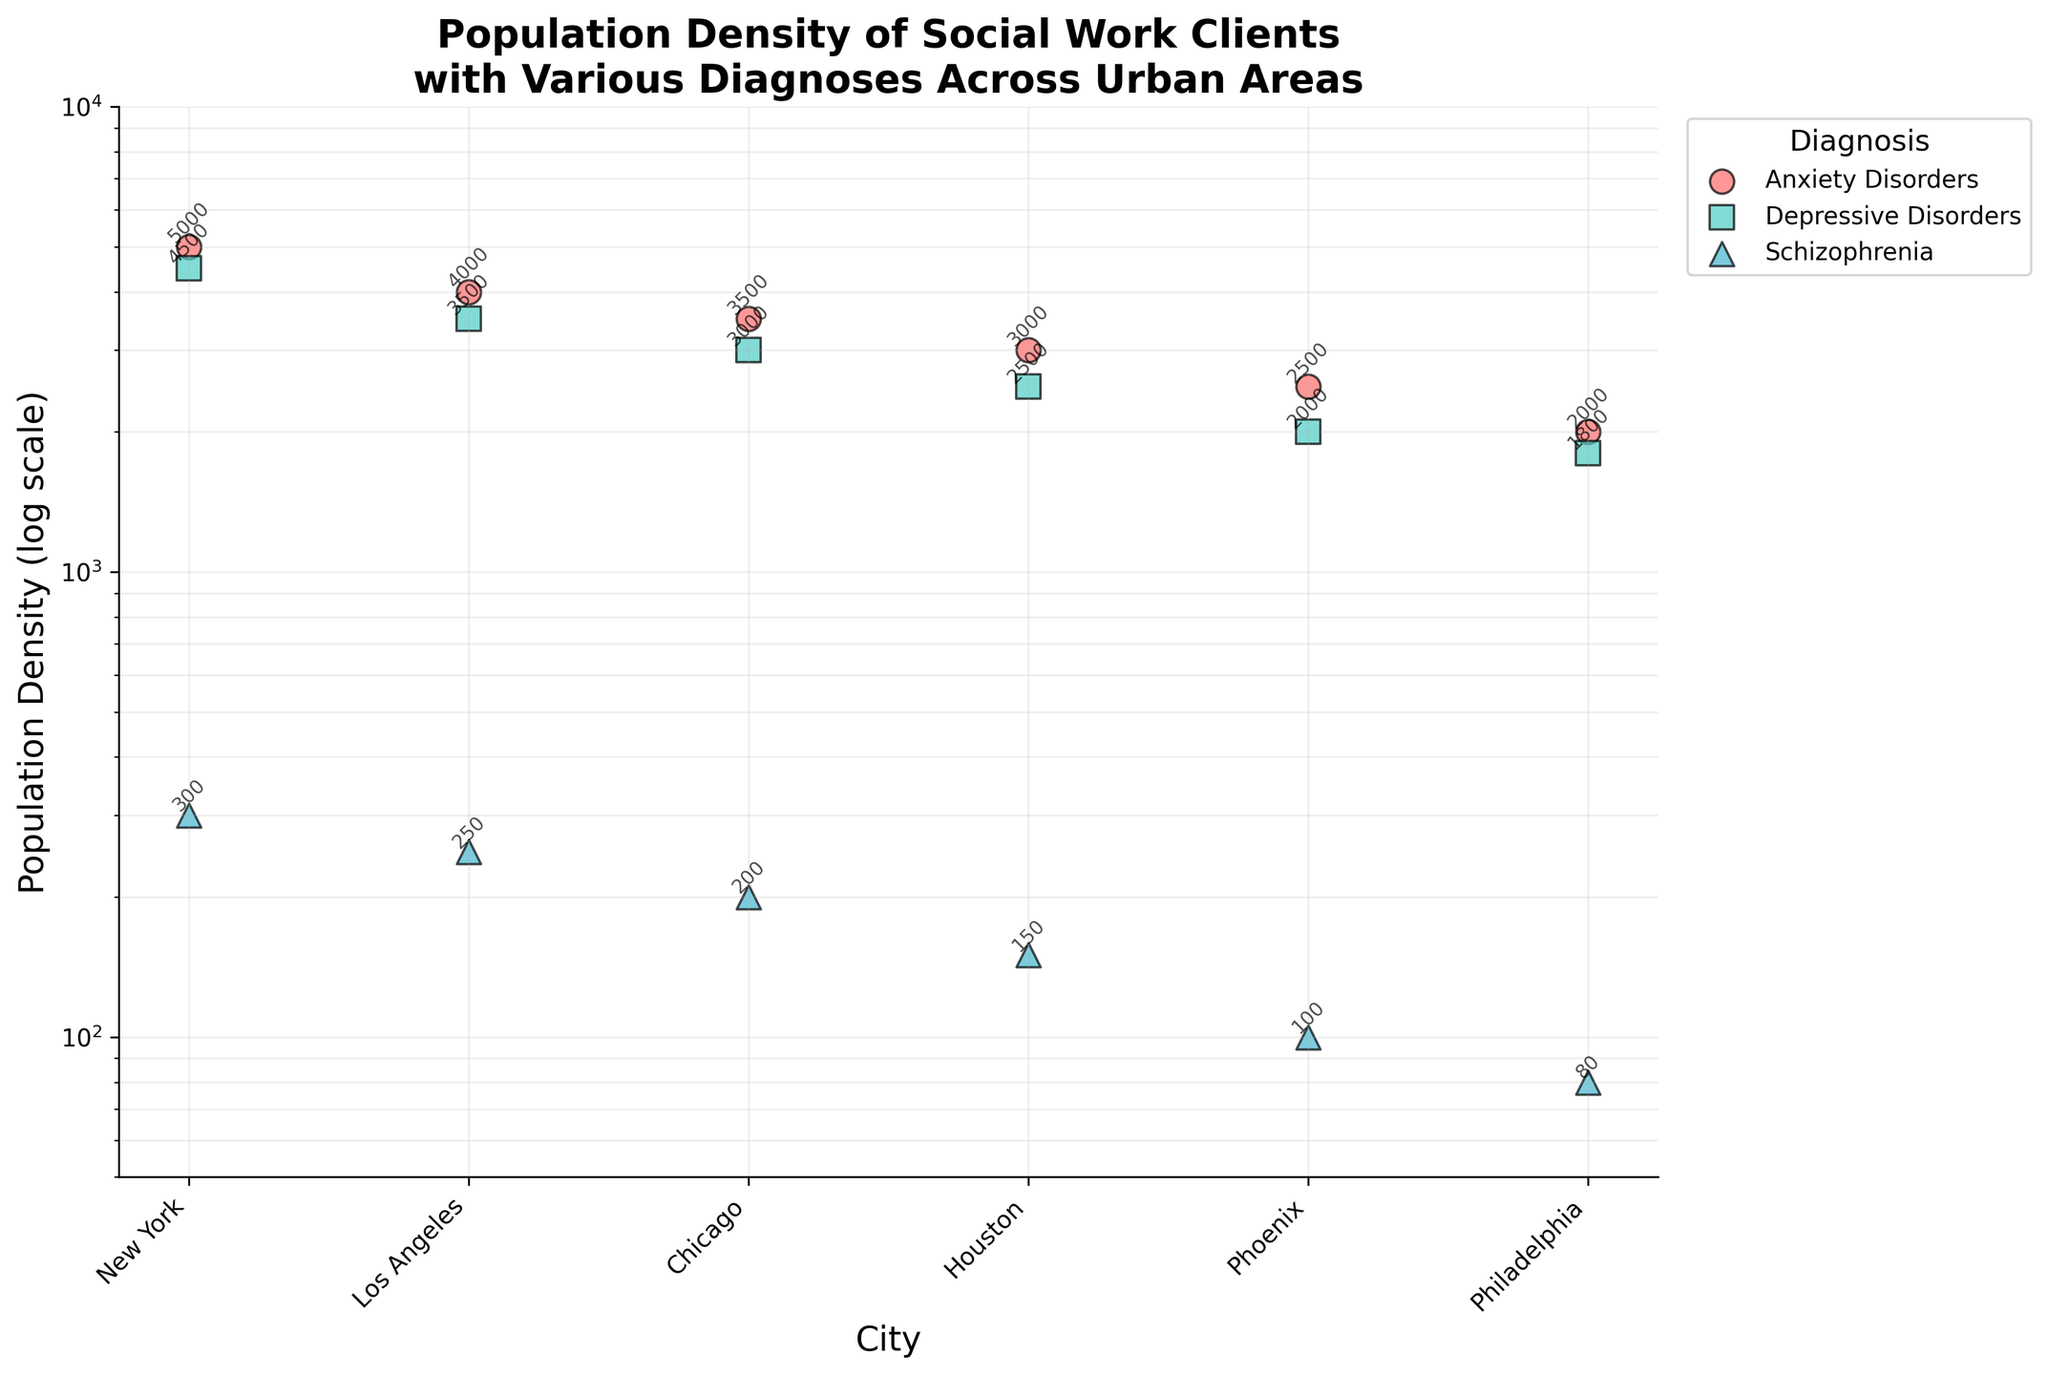What is the title of the plot? The title of the plot is usually found at the top of the figure and summarizes the content. Here it reads "Population Density of Social Work Clients with Various Diagnoses Across Urban Areas."
Answer: Population Density of Social Work Clients with Various Diagnoses Across Urban Areas Which city has the highest population density of clients with Anxiety Disorders? By looking at the y-axis for the data points labeled "Anxiety Disorders" across each city, it's evident that New York has the highest value at 5,000.
Answer: New York What is the approximate population density difference between Depressive Disorders and Schizophrenia in Los Angeles? In Los Angeles, the population density for Depressive Disorders is 3,500, and for Schizophrenia, it is 250. Subtracting these values gives the difference: 3500 - 250 = 3,250.
Answer: 3,250 Which diagnosis appears to have the lowest population density across all cities, and what is its value? By observing the y-axis values for each diagnosis, Schizophrenia in Philadelphia has the lowest population density at 80.
Answer: Schizophrenia, 80 How does the population density of Anxiety Disorders in Phoenix compare to Depressive Disorders in Philadelphia? On the y-axis, Anxiety Disorders in Phoenix is at 2,500, and Depressive Disorders in Philadelphia is at 1,800. 2,500 is greater than 1,800.
Answer: Anxiety Disorders in Phoenix is greater Among Chicago and Houston, which city has a higher population density for Depressive Disorders? Checking the y-values, Chicago has a population density of 3,000 for Depressive Disorders, while Houston has 2,500.
Answer: Chicago What is the ratio of the population density of Anxiety Disorders in New York compared to Schizophrenia in Houston? The population density for Anxiety Disorders in New York is 5,000, and for Schizophrenia in Houston it is 150. The ratio is 5000 / 150 ≈ 33.33.
Answer: 33.33 Which diagnoses have population densities below 200 in any city? By inspecting the y-values, Schizophrenia in Houston (150), Phoenix (100), and Philadelphia (80) all have values below 200.
Answer: Schizophrenia What is the average population density of clients with Depressive Disorders across all cities? Summing the population densities of Depressive Disorders: 4500 (NY) + 3500 (LA) + 3000 (Chicago) + 2500 (Houston) + 2000 (Phoenix) + 1800 (Philadelphia) = 17300. Dividing by the number of cities (6) gives 17300 / 6 ≈ 2883.33.
Answer: 2883.33 Which city has the smallest spread (difference between highest and lowest values) in population density across all diagnoses? Calculate the spread for each city:
  - New York: 5000 (AD) - 300 (Schiz) = 4700
  - Los Angeles: 4000 (AD) - 250 (Schiz) = 3750
  - Chicago: 3500 (AD) - 200 (Schiz) = 3300
  - Houston: 3000 (AD) - 150 (Schiz) = 2850
  - Phoenix: 2500 (AD) - 100 (Schiz) = 2400
  - Philadelphia: 2000 (AD) - 80 (Schiz) = 1920
 The smallest spread is in Philadelphia, 1920.
Answer: Philadelphia, 1920 